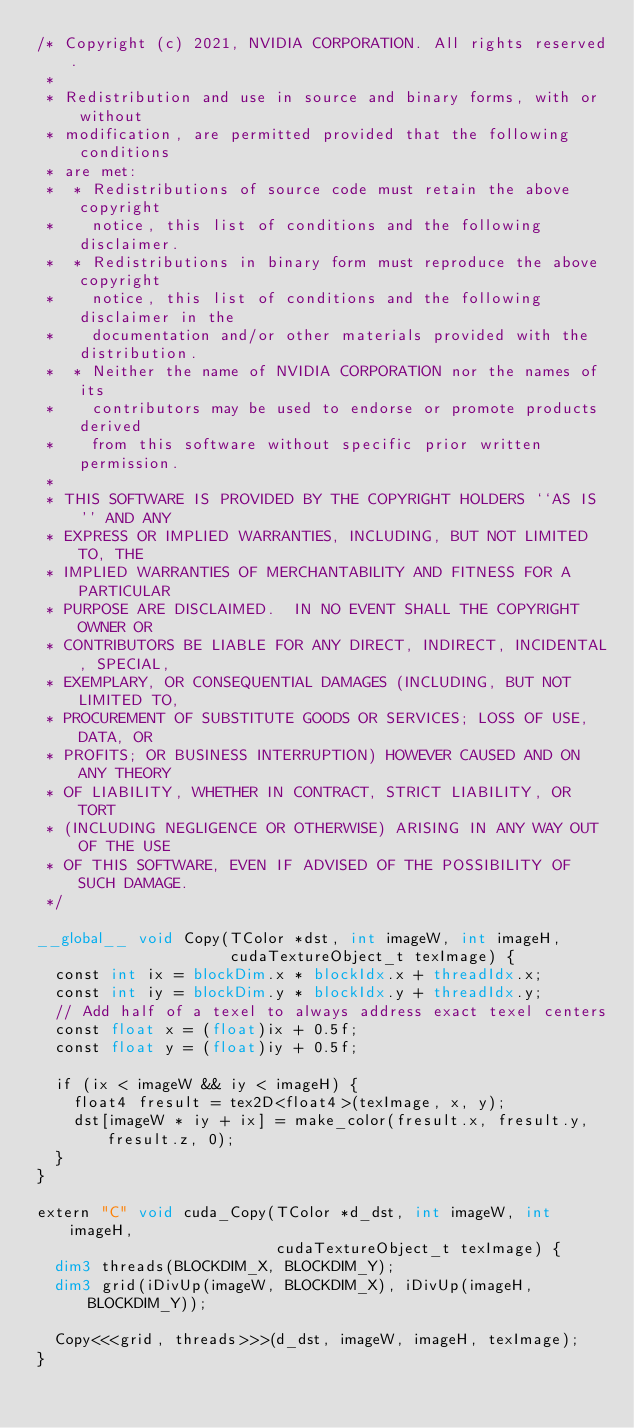Convert code to text. <code><loc_0><loc_0><loc_500><loc_500><_Cuda_>/* Copyright (c) 2021, NVIDIA CORPORATION. All rights reserved.
 *
 * Redistribution and use in source and binary forms, with or without
 * modification, are permitted provided that the following conditions
 * are met:
 *  * Redistributions of source code must retain the above copyright
 *    notice, this list of conditions and the following disclaimer.
 *  * Redistributions in binary form must reproduce the above copyright
 *    notice, this list of conditions and the following disclaimer in the
 *    documentation and/or other materials provided with the distribution.
 *  * Neither the name of NVIDIA CORPORATION nor the names of its
 *    contributors may be used to endorse or promote products derived
 *    from this software without specific prior written permission.
 *
 * THIS SOFTWARE IS PROVIDED BY THE COPYRIGHT HOLDERS ``AS IS'' AND ANY
 * EXPRESS OR IMPLIED WARRANTIES, INCLUDING, BUT NOT LIMITED TO, THE
 * IMPLIED WARRANTIES OF MERCHANTABILITY AND FITNESS FOR A PARTICULAR
 * PURPOSE ARE DISCLAIMED.  IN NO EVENT SHALL THE COPYRIGHT OWNER OR
 * CONTRIBUTORS BE LIABLE FOR ANY DIRECT, INDIRECT, INCIDENTAL, SPECIAL,
 * EXEMPLARY, OR CONSEQUENTIAL DAMAGES (INCLUDING, BUT NOT LIMITED TO,
 * PROCUREMENT OF SUBSTITUTE GOODS OR SERVICES; LOSS OF USE, DATA, OR
 * PROFITS; OR BUSINESS INTERRUPTION) HOWEVER CAUSED AND ON ANY THEORY
 * OF LIABILITY, WHETHER IN CONTRACT, STRICT LIABILITY, OR TORT
 * (INCLUDING NEGLIGENCE OR OTHERWISE) ARISING IN ANY WAY OUT OF THE USE
 * OF THIS SOFTWARE, EVEN IF ADVISED OF THE POSSIBILITY OF SUCH DAMAGE.
 */

__global__ void Copy(TColor *dst, int imageW, int imageH,
                     cudaTextureObject_t texImage) {
  const int ix = blockDim.x * blockIdx.x + threadIdx.x;
  const int iy = blockDim.y * blockIdx.y + threadIdx.y;
  // Add half of a texel to always address exact texel centers
  const float x = (float)ix + 0.5f;
  const float y = (float)iy + 0.5f;

  if (ix < imageW && iy < imageH) {
    float4 fresult = tex2D<float4>(texImage, x, y);
    dst[imageW * iy + ix] = make_color(fresult.x, fresult.y, fresult.z, 0);
  }
}

extern "C" void cuda_Copy(TColor *d_dst, int imageW, int imageH,
                          cudaTextureObject_t texImage) {
  dim3 threads(BLOCKDIM_X, BLOCKDIM_Y);
  dim3 grid(iDivUp(imageW, BLOCKDIM_X), iDivUp(imageH, BLOCKDIM_Y));

  Copy<<<grid, threads>>>(d_dst, imageW, imageH, texImage);
}
</code> 